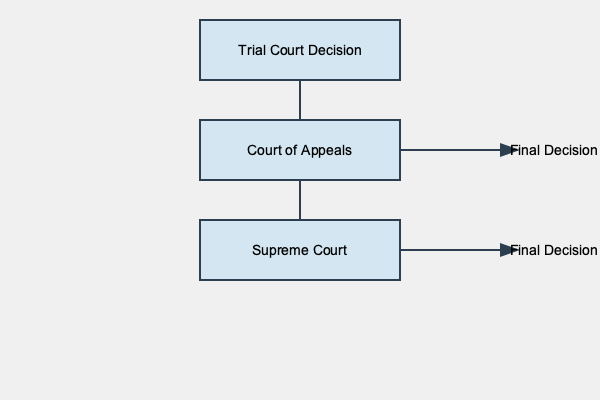Based on the flowchart of the appeals process in the judicial system, at which stage can a case potentially reach its final decision without proceeding to the highest court? To answer this question, we need to analyze the flowchart step-by-step:

1. The process begins at the Trial Court Decision level, which is the first box in the flowchart.

2. From there, an arrow leads to the Court of Appeals, indicating that a case can be appealed from the trial court to this higher court.

3. The Court of Appeals has two potential outcomes:
   a. An arrow leads to the Supreme Court, suggesting that the case can be further appealed.
   b. An arrow leads to "Final Decision," indicating that the case can reach its conclusion at this stage.

4. The Supreme Court, being the highest court, only has an arrow leading to "Final Decision."

5. The key observation is that there's a "Final Decision" option stemming from the Court of Appeals, which means a case can potentially end at this stage without proceeding to the Supreme Court.

Therefore, the Court of Appeals is the stage at which a case can reach its final decision without going to the highest court (Supreme Court) in this appeals process.
Answer: Court of Appeals 